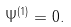Convert formula to latex. <formula><loc_0><loc_0><loc_500><loc_500>\Psi ^ { ( 1 ) } = 0 .</formula> 